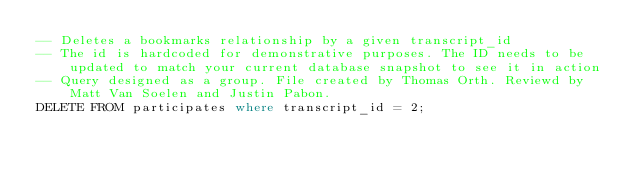<code> <loc_0><loc_0><loc_500><loc_500><_SQL_>-- Deletes a bookmarks relationship by a given transcript_id
-- The id is hardcoded for demonstrative purposes. The ID needs to be updated to match your current database snapshot to see it in action
-- Query designed as a group. File created by Thomas Orth. Reviewd by Matt Van Soelen and Justin Pabon.
DELETE FROM participates where transcript_id = 2;</code> 